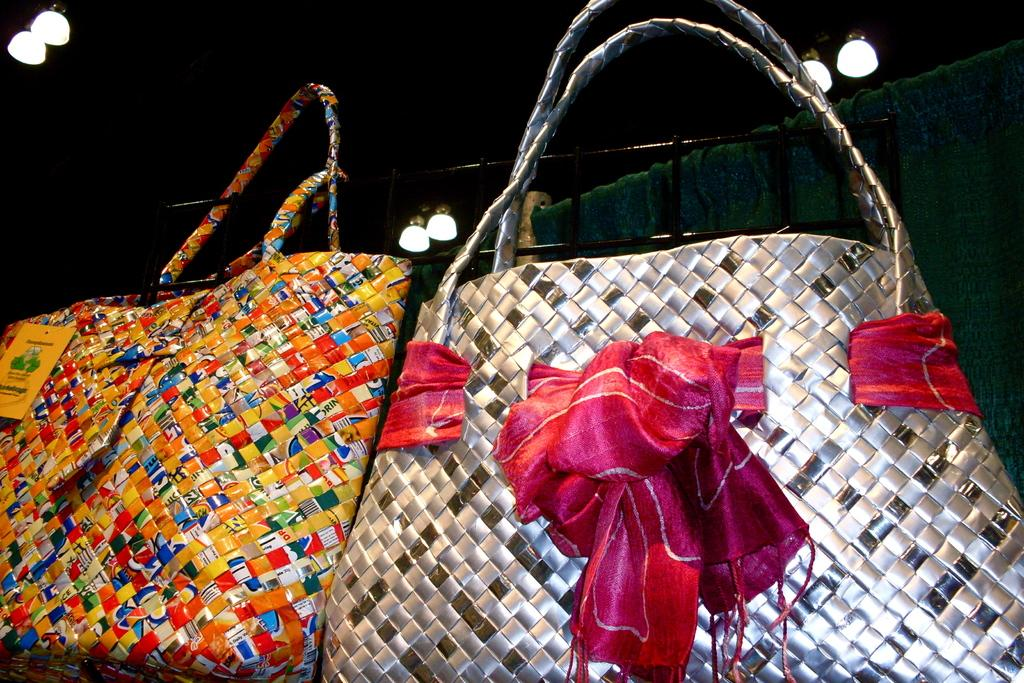How many bags can be seen in the image? There are two bags in the image. Can you describe the appearance of the silver bag? The silver bag has a ribbon around it. What is the color pattern of the other bag? The other bag is multicolored. What is located on the roof in the image? There are lights on the roof in the image. What type of harmony is being played in the image? There is no indication of music or harmony in the image; it features two bags and lights on the roof. 